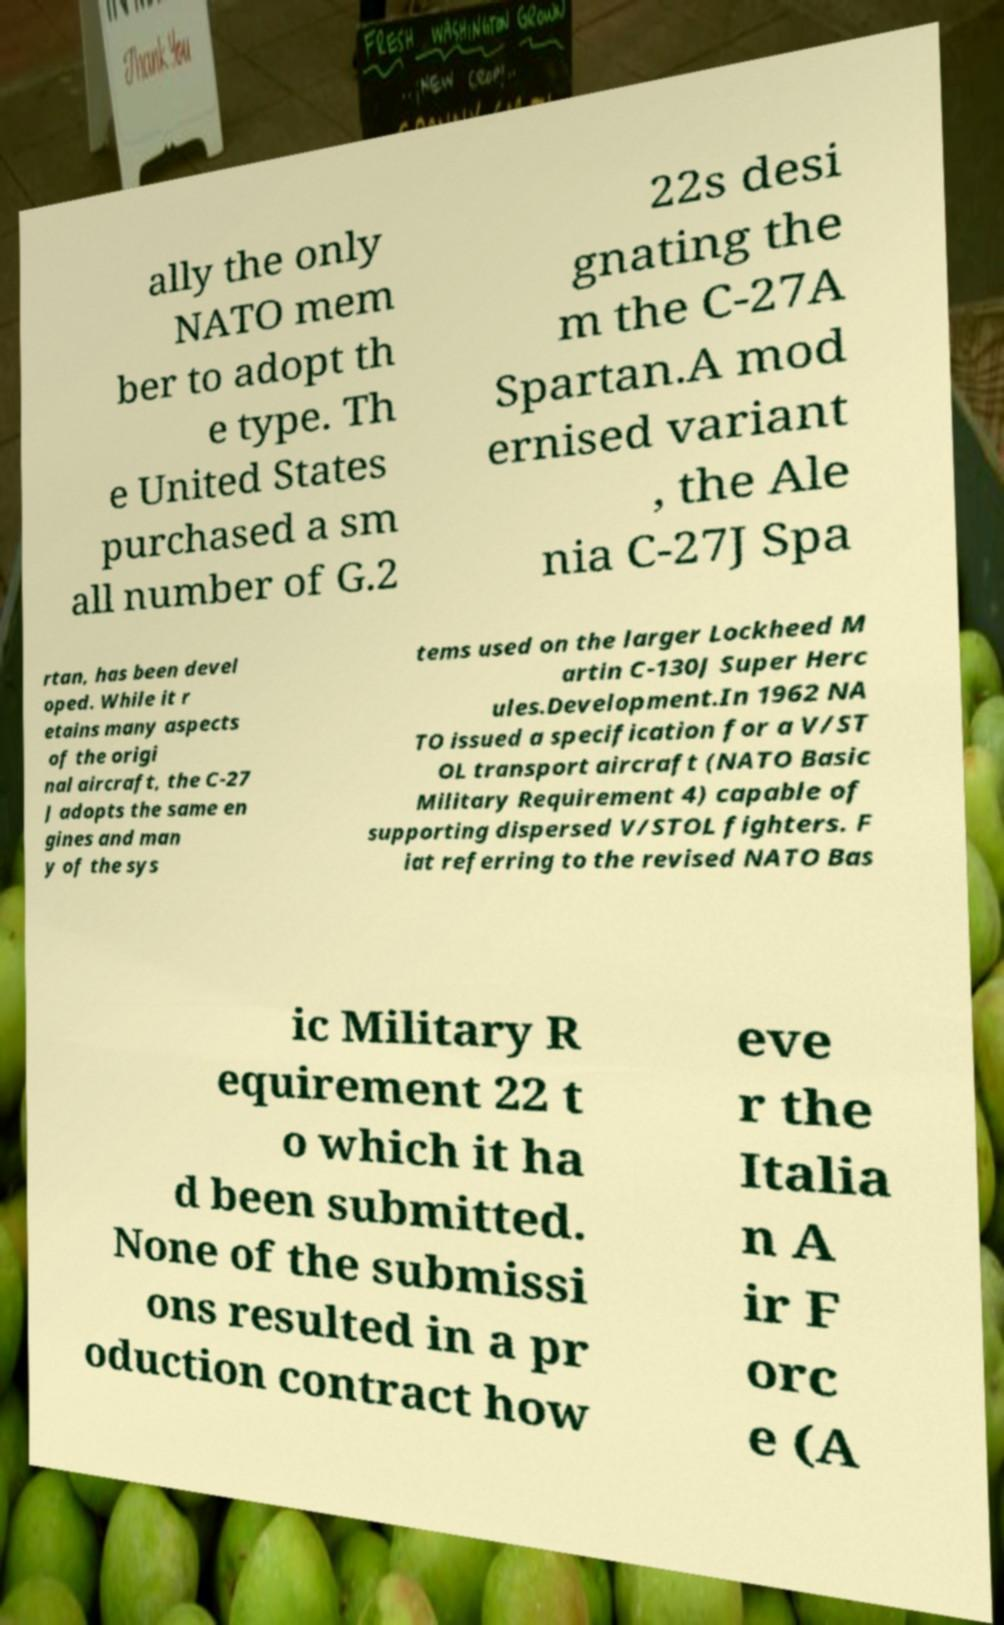For documentation purposes, I need the text within this image transcribed. Could you provide that? ally the only NATO mem ber to adopt th e type. Th e United States purchased a sm all number of G.2 22s desi gnating the m the C-27A Spartan.A mod ernised variant , the Ale nia C-27J Spa rtan, has been devel oped. While it r etains many aspects of the origi nal aircraft, the C-27 J adopts the same en gines and man y of the sys tems used on the larger Lockheed M artin C-130J Super Herc ules.Development.In 1962 NA TO issued a specification for a V/ST OL transport aircraft (NATO Basic Military Requirement 4) capable of supporting dispersed V/STOL fighters. F iat referring to the revised NATO Bas ic Military R equirement 22 t o which it ha d been submitted. None of the submissi ons resulted in a pr oduction contract how eve r the Italia n A ir F orc e (A 